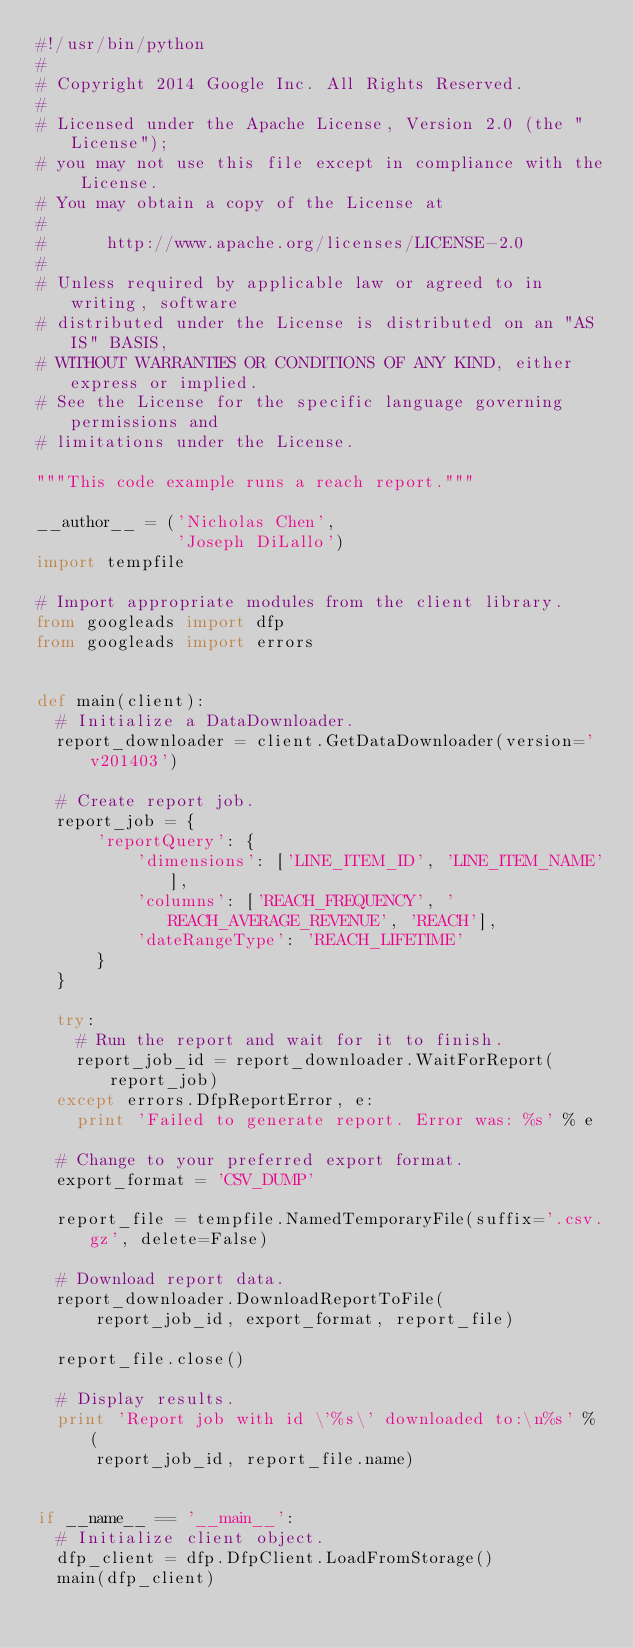<code> <loc_0><loc_0><loc_500><loc_500><_Python_>#!/usr/bin/python
#
# Copyright 2014 Google Inc. All Rights Reserved.
#
# Licensed under the Apache License, Version 2.0 (the "License");
# you may not use this file except in compliance with the License.
# You may obtain a copy of the License at
#
#      http://www.apache.org/licenses/LICENSE-2.0
#
# Unless required by applicable law or agreed to in writing, software
# distributed under the License is distributed on an "AS IS" BASIS,
# WITHOUT WARRANTIES OR CONDITIONS OF ANY KIND, either express or implied.
# See the License for the specific language governing permissions and
# limitations under the License.

"""This code example runs a reach report."""

__author__ = ('Nicholas Chen',
              'Joseph DiLallo')
import tempfile

# Import appropriate modules from the client library.
from googleads import dfp
from googleads import errors


def main(client):
  # Initialize a DataDownloader.
  report_downloader = client.GetDataDownloader(version='v201403')

  # Create report job.
  report_job = {
      'reportQuery': {
          'dimensions': ['LINE_ITEM_ID', 'LINE_ITEM_NAME'],
          'columns': ['REACH_FREQUENCY', 'REACH_AVERAGE_REVENUE', 'REACH'],
          'dateRangeType': 'REACH_LIFETIME'
      }
  }

  try:
    # Run the report and wait for it to finish.
    report_job_id = report_downloader.WaitForReport(report_job)
  except errors.DfpReportError, e:
    print 'Failed to generate report. Error was: %s' % e

  # Change to your preferred export format.
  export_format = 'CSV_DUMP'

  report_file = tempfile.NamedTemporaryFile(suffix='.csv.gz', delete=False)

  # Download report data.
  report_downloader.DownloadReportToFile(
      report_job_id, export_format, report_file)

  report_file.close()

  # Display results.
  print 'Report job with id \'%s\' downloaded to:\n%s' % (
      report_job_id, report_file.name)


if __name__ == '__main__':
  # Initialize client object.
  dfp_client = dfp.DfpClient.LoadFromStorage()
  main(dfp_client)
</code> 